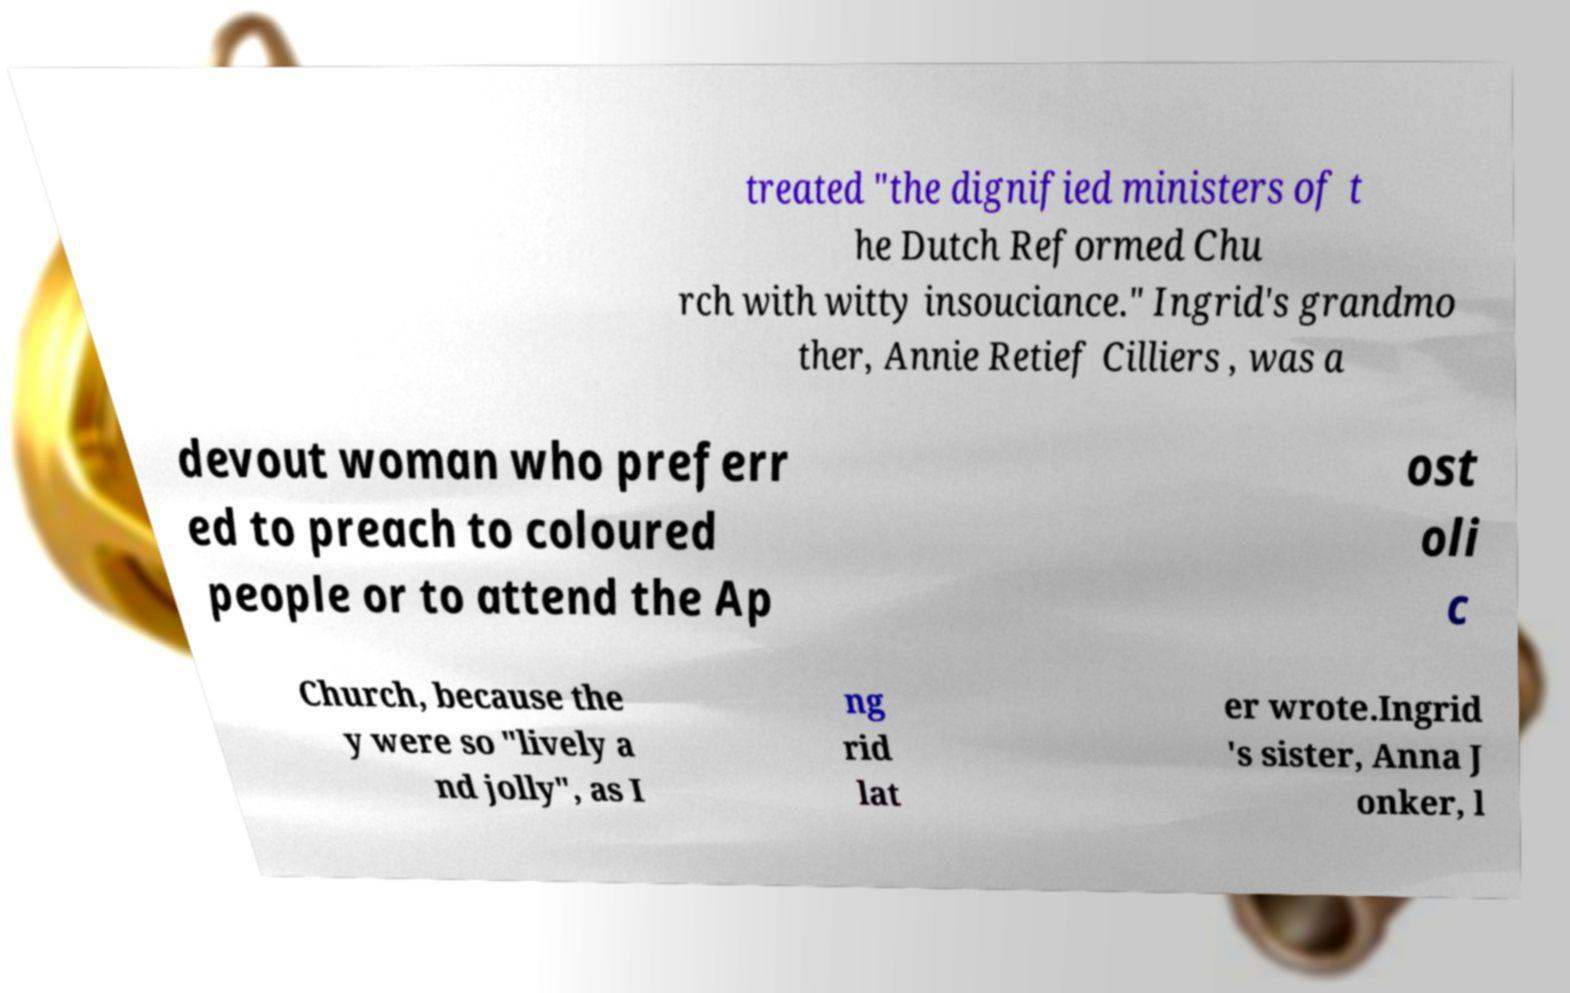Please identify and transcribe the text found in this image. treated "the dignified ministers of t he Dutch Reformed Chu rch with witty insouciance." Ingrid's grandmo ther, Annie Retief Cilliers , was a devout woman who preferr ed to preach to coloured people or to attend the Ap ost oli c Church, because the y were so "lively a nd jolly", as I ng rid lat er wrote.Ingrid 's sister, Anna J onker, l 